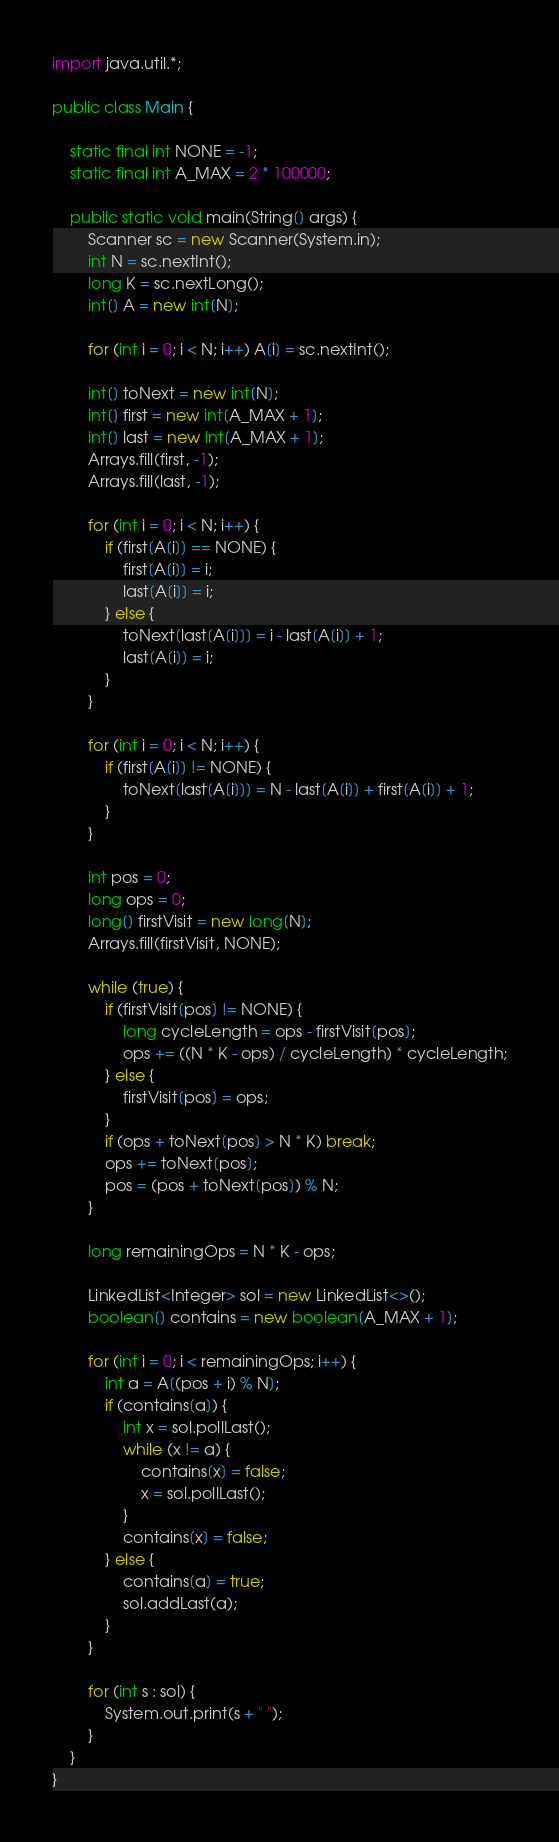<code> <loc_0><loc_0><loc_500><loc_500><_Java_>import java.util.*;

public class Main {

    static final int NONE = -1;
    static final int A_MAX = 2 * 100000;

    public static void main(String[] args) {
        Scanner sc = new Scanner(System.in);
        int N = sc.nextInt();
        long K = sc.nextLong();
        int[] A = new int[N];

        for (int i = 0; i < N; i++) A[i] = sc.nextInt();

        int[] toNext = new int[N];
        int[] first = new int[A_MAX + 1];
        int[] last = new int[A_MAX + 1];
        Arrays.fill(first, -1);
        Arrays.fill(last, -1);

        for (int i = 0; i < N; i++) {
            if (first[A[i]] == NONE) {
                first[A[i]] = i;
                last[A[i]] = i;
            } else {
                toNext[last[A[i]]] = i - last[A[i]] + 1;
                last[A[i]] = i;
            }
        }

        for (int i = 0; i < N; i++) {
            if (first[A[i]] != NONE) {
                toNext[last[A[i]]] = N - last[A[i]] + first[A[i]] + 1;
            }
        }

        int pos = 0;
        long ops = 0;
        long[] firstVisit = new long[N];
        Arrays.fill(firstVisit, NONE);

        while (true) {
            if (firstVisit[pos] != NONE) {
                long cycleLength = ops - firstVisit[pos];
                ops += ((N * K - ops) / cycleLength) * cycleLength;
            } else {
                firstVisit[pos] = ops;
            }
            if (ops + toNext[pos] > N * K) break;
            ops += toNext[pos];
            pos = (pos + toNext[pos]) % N;
        }

        long remainingOps = N * K - ops;

        LinkedList<Integer> sol = new LinkedList<>();
        boolean[] contains = new boolean[A_MAX + 1];

        for (int i = 0; i < remainingOps; i++) {
            int a = A[(pos + i) % N];
            if (contains[a]) {
                int x = sol.pollLast();
                while (x != a) {
                    contains[x] = false;
                    x = sol.pollLast();
                }
                contains[x] = false;
            } else {
                contains[a] = true;
                sol.addLast(a);
            }
        }

        for (int s : sol) {
            System.out.print(s + " ");
        }
    }
}
</code> 